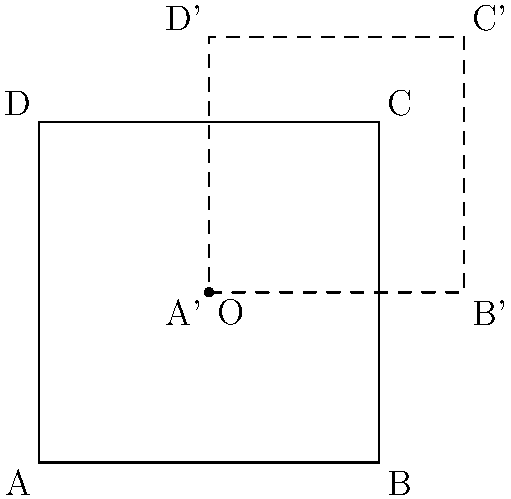A rectangle ABCD with center O is scaled by a factor of 1.5 from its center point. If the original area of the rectangle was 16 square units, what is the area of the new rectangle A'B'C'D'? Let's approach this step-by-step:

1) First, we need to understand what scaling by a factor of 1.5 means:
   - Each dimension of the rectangle will be multiplied by 1.5

2) Let's consider the relationship between the sides of the original and new rectangles:
   - If we denote the width of the original rectangle as $w$ and the height as $h$, then:
   - New width = $1.5w$
   - New height = $1.5h$

3) Now, let's look at the areas:
   - Original area = $w * h = 16$ square units
   - New area = $(1.5w) * (1.5h) = 1.5^2 * (w*h)$

4) We can simplify this:
   - New area = $1.5^2 * 16 = 2.25 * 16 = 36$ square units

Therefore, the area of the new rectangle A'B'C'D' is 36 square units.
Answer: 36 square units 